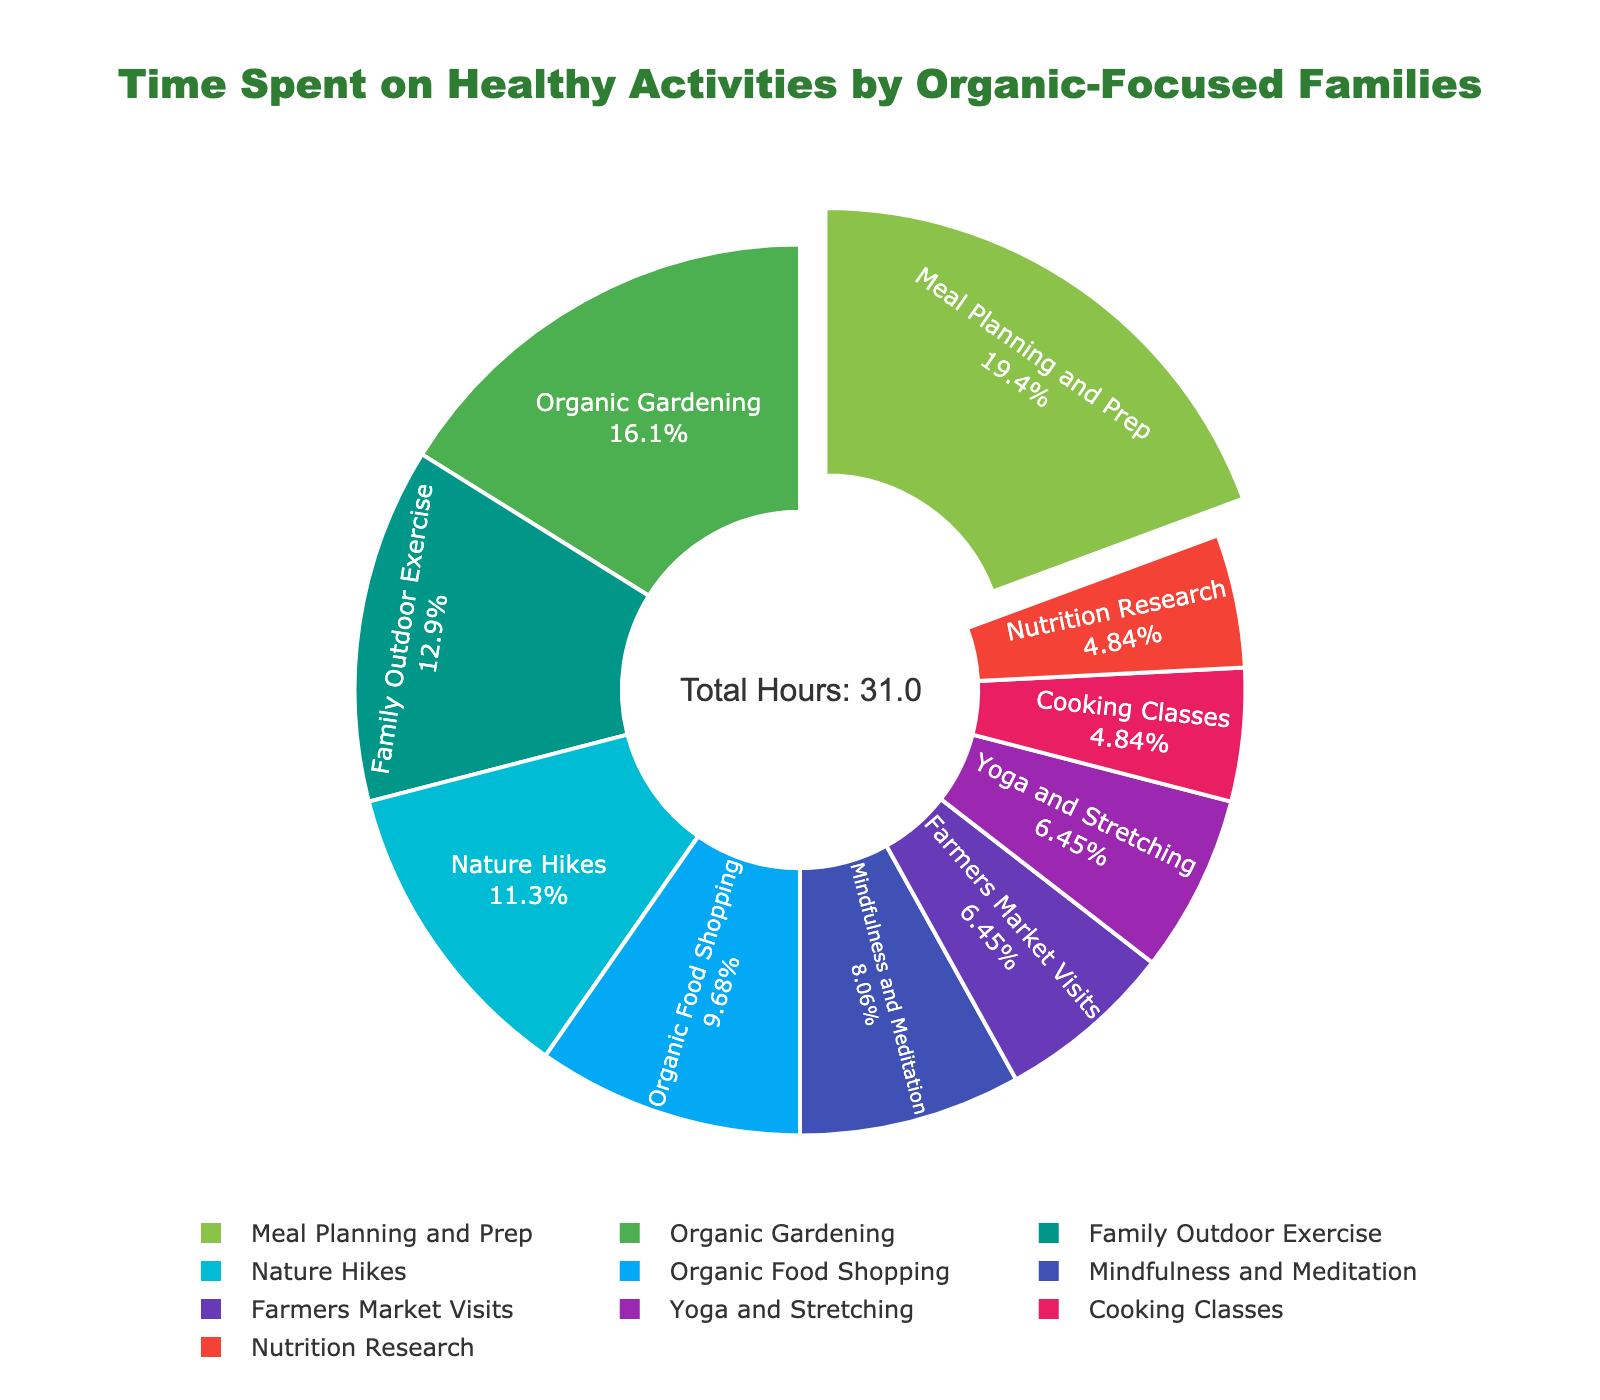What's the largest activity in terms of time spent per week? From the figure, the activity that occupies the largest section is identified by looking for the segment with the highest percentage.
Answer: Meal Planning and Prep Which two activities are spent the least amount of time on? Identify the smallest two segments in the pie chart by observing the percentages associated with each segment.
Answer: Cooking Classes, Nutrition Research What percentage of time is spent on Yoga and Stretching compared to Organic Gardening? Determine the percentages for Yoga and Stretching and Organic Gardening from the figure, then compare them directly.
Answer: 2% compared to 5% Is more time spent on Farmers Market Visits or Mindfulness and Meditation? Compare the segments for Farmers Market Visits and Mindfulness and Meditation based on their size and associated percentage.
Answer: Mindfulness and Meditation How much total time is spent on activities that involve physical exercise? Sum the time spent on Family Outdoor Exercise, Nature Hikes, and Yoga and Stretching based on the percentages listed.
Answer: 9.5 hours What's the difference in the time spent between Organic Food Shopping and Nature Hikes? Subtract the percentage of Nature Hikes from Organic Food Shopping.
Answer: 0.5% What fraction of time is spent on Cooking Classes and Nutrition Research combined? Add up the percentages of Cooking Classes and Nutrition Research from the figure.
Answer: 3% Are Farmers Market Visits and Yoga and Stretching combined greater or less than Organic Gardening? Combine the percentages of Farmers Market Visits and Yoga and Stretching, and compare the sum with the percentage for Organic Gardening.
Answer: Less (4% vs. 5%) Which activity's color is used to highlight the largest section? Identify the color associated with the largest segment in the pie chart.
Answer: Green (Meal Planning and Prep) Is the total time spent on mindfulness and meditation activities (Mindfulness and Meditation, and Yoga and Stretching) greater than the time spent on Meal Planning and Prep? Add the percentages for Mindfulness and Meditation, and Yoga and Stretching, then compare it with Meal Planning and Prep.
Answer: No (4.5% vs. 6%) 